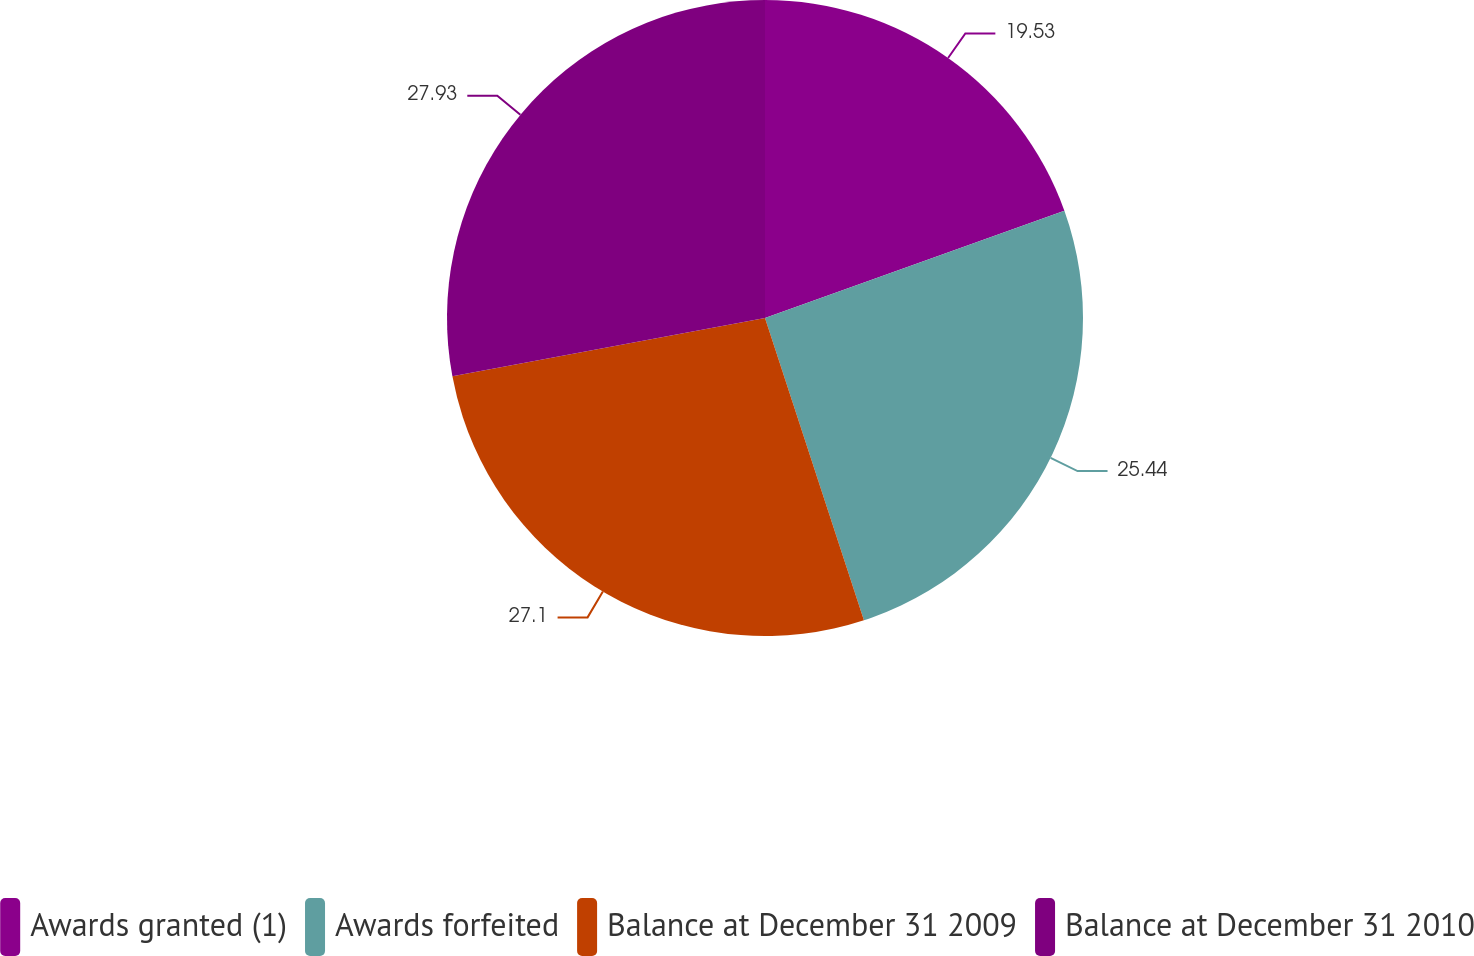Convert chart to OTSL. <chart><loc_0><loc_0><loc_500><loc_500><pie_chart><fcel>Awards granted (1)<fcel>Awards forfeited<fcel>Balance at December 31 2009<fcel>Balance at December 31 2010<nl><fcel>19.53%<fcel>25.44%<fcel>27.1%<fcel>27.94%<nl></chart> 